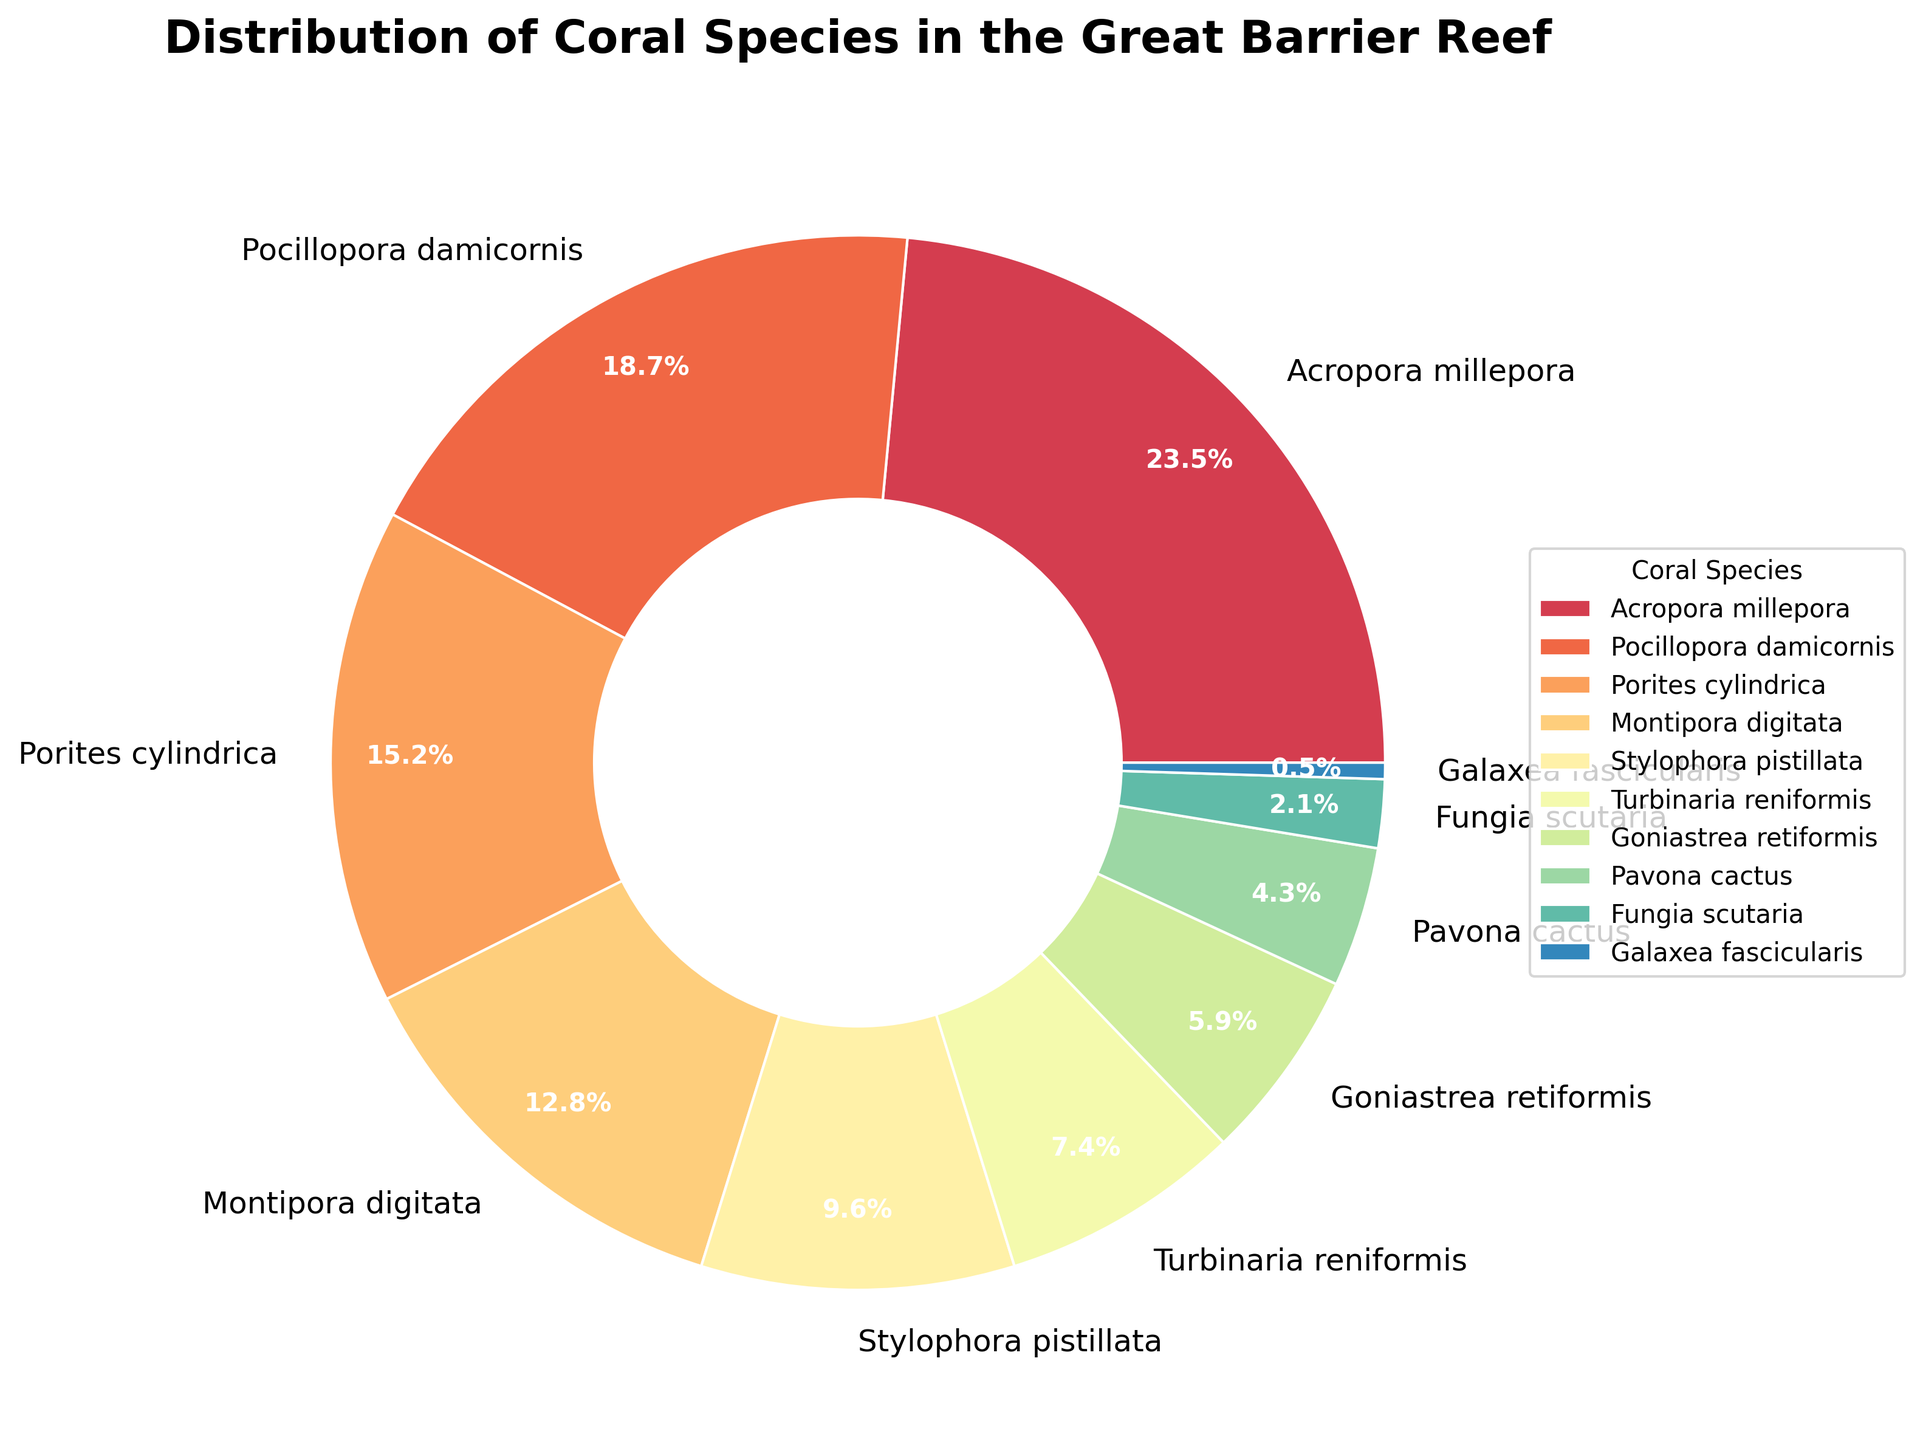Which coral species has the highest percentage distribution in the Great Barrier Reef? By observing the segments, the largest wedge in the pie chart corresponds to the species with the highest percentage. The label on that wedge indicates it is "Acropora millepora".
Answer: Acropora millepora What is the combined percentage of the three most abundant coral species in the Great Barrier Reef? Sum the percentages of the top three species: Acropora millepora (23.5%), Pocillopora damicornis (18.7%), and Porites cylindrica (15.2%). The total is 23.5 + 18.7 + 15.2 = 57.4%.
Answer: 57.4% Which species contributes less than 3% to the total distribution? Identify the species whose wedge has a label with a percentage less than 3%. "Fungia scutaria" has 2.1%, and "Galaxea fascicularis" has 0.5%.
Answer: Fungia scutaria, Galaxea fascicularis By how much does the percentage of Acropora millepora exceed that of Montipora digitata? Find the difference between the percentages of Acropora millepora (23.5%) and Montipora digitata (12.8%). Calculate 23.5 - 12.8 = 10.7.
Answer: 10.7% What is the average percentage distribution of Turbinaria reniformis and Pavona cactus? Calculate the average of the percentages for Turbinaria reniformis (7.4%) and Pavona cactus (4.3%). The average is (7.4 + 4.3) / 2 = 5.85%.
Answer: 5.85% How many coral species have a percentage distribution of more than 10%? Count the species with percentage values greater than 10%. The species are Acropora millepora (23.5%), Pocillopora damicornis (18.7%), Porites cylindrica (15.2%), and Montipora digitata (12.8%), which totals four species.
Answer: Four Which coral species has the smallest percentage distribution in the Great Barrier Reef? Determine the smallest wedge in the pie chart and read its label. The smallest wedge corresponds to "Galaxea fascicularis" with 0.5%.
Answer: Galaxea fascicularis What is the total percentage contribution of Stylophora pistillata and Goniastrea retiformis combined? Sum the percentages of Stylophora pistillata (9.6%) and Goniastrea retiformis (5.9%). The total is 9.6 + 5.9 = 15.5%.
Answer: 15.5% Is the percentage distribution of Pocillopora damicornis greater than twice that of Pavona cactus? Check if the percentage for Pocillopora damicornis (18.7%) is greater than twice the percentage of Pavona cactus by calculating 2 * 4.3 = 8.6. Since 18.7 is greater than 8.6, the statement is true.
Answer: Yes What is the difference between the percentage distributions of Stylophora pistillata and Turbinaria reniformis? Calculate the difference between the percentages for Stylophora pistillata (9.6%) and Turbinaria reniformis (7.4%). The difference is 9.6 - 7.4 = 2.2.
Answer: 2.2% 